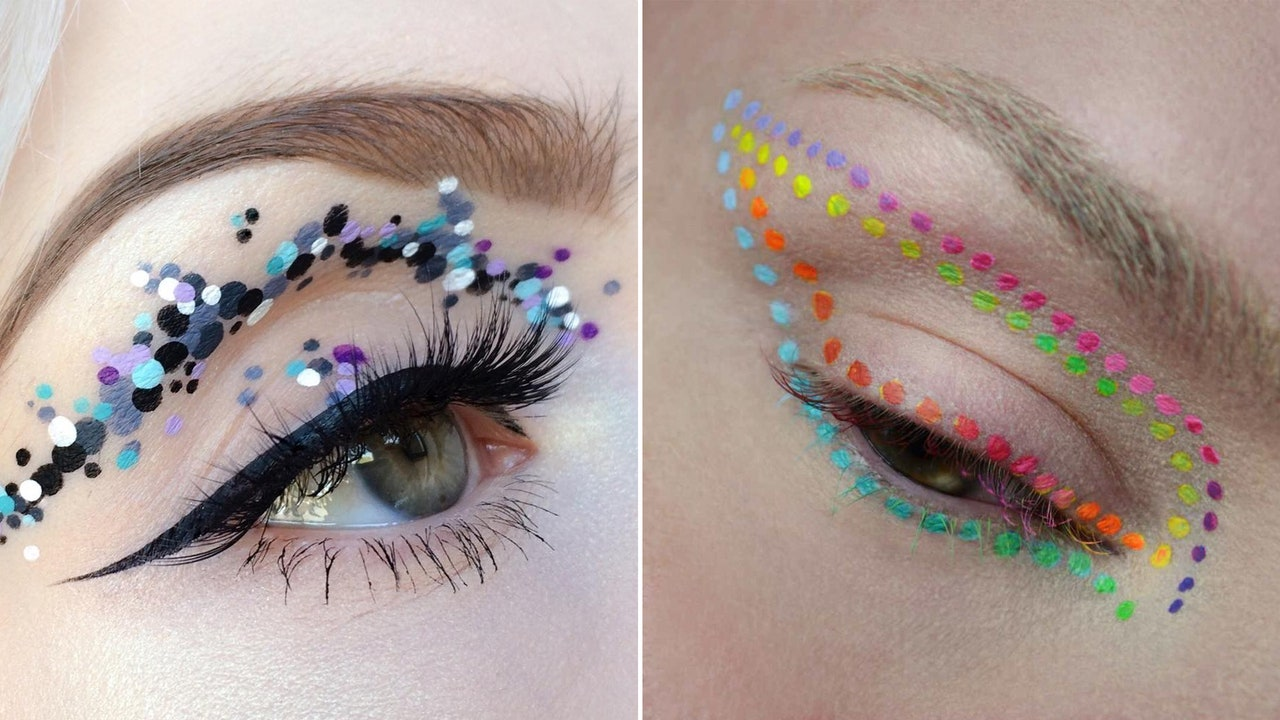How do these makeup designs reflect current trends in fashion? These makeup designs reflect current fashion trends that emphasize personal expression and artistic freedom. The use of vibrant colors and unconventional materials like sequins and face paints aligns with the modern trend of embracing bold, statement looks. The designs also mirror the widespread interest in crafting distinctive, memorable appearances, often seen in high-fashion editorials and runway shows. 